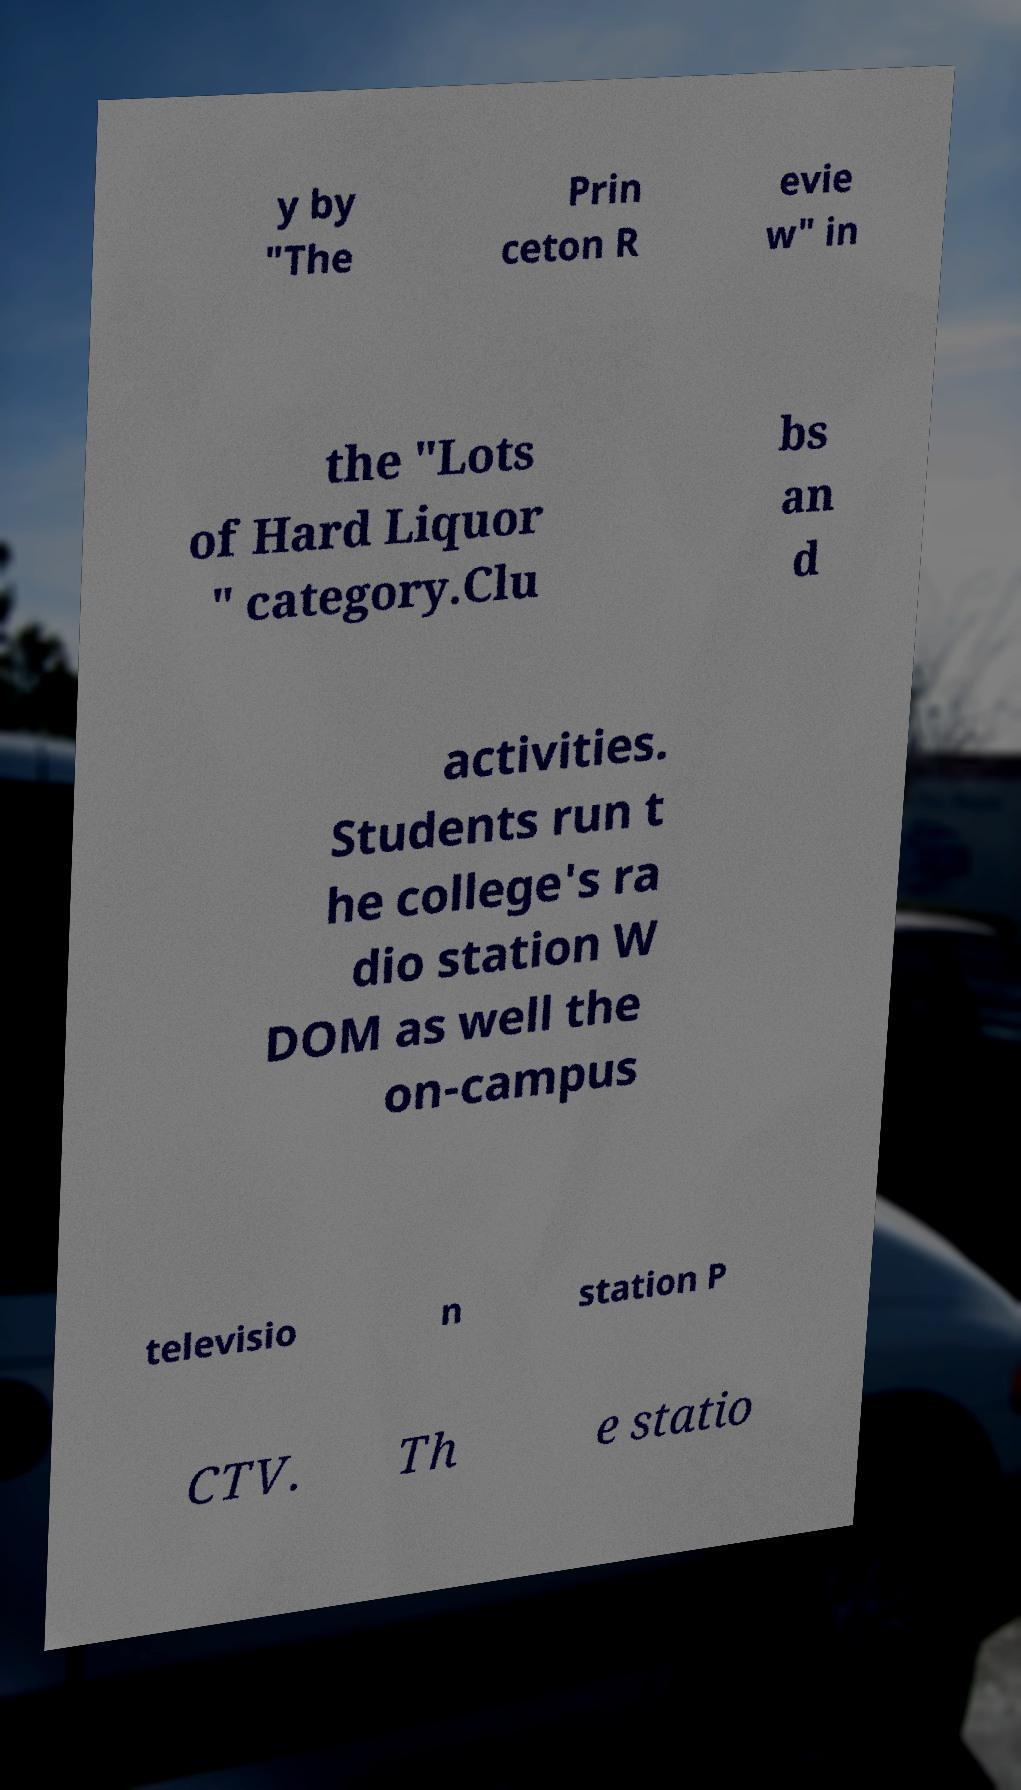Could you extract and type out the text from this image? y by "The Prin ceton R evie w" in the "Lots of Hard Liquor " category.Clu bs an d activities. Students run t he college's ra dio station W DOM as well the on-campus televisio n station P CTV. Th e statio 